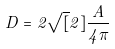Convert formula to latex. <formula><loc_0><loc_0><loc_500><loc_500>D = 2 \sqrt { [ } 2 ] { \frac { A } { 4 \pi } }</formula> 